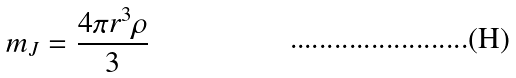Convert formula to latex. <formula><loc_0><loc_0><loc_500><loc_500>m _ { J } = { \frac { { 4 \pi r ^ { 3 } \rho } } { 3 } }</formula> 